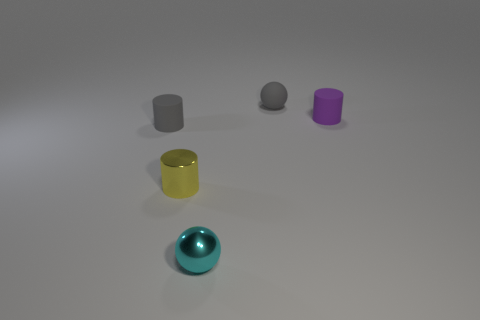Subtract all tiny yellow metallic cylinders. How many cylinders are left? 2 Add 3 tiny cyan metallic things. How many objects exist? 8 Subtract 1 balls. How many balls are left? 1 Subtract all gray spheres. How many spheres are left? 1 Subtract all cylinders. How many objects are left? 2 Subtract all brown cylinders. How many cyan balls are left? 1 Subtract all tiny gray rubber objects. Subtract all purple rubber cylinders. How many objects are left? 2 Add 5 small purple rubber cylinders. How many small purple rubber cylinders are left? 6 Add 2 matte cylinders. How many matte cylinders exist? 4 Subtract 0 brown spheres. How many objects are left? 5 